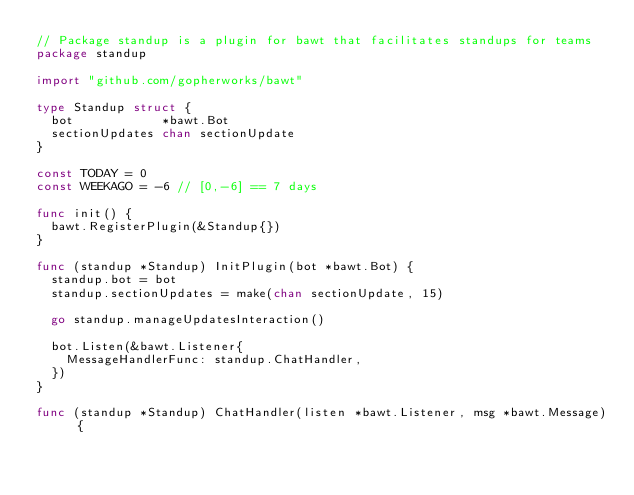<code> <loc_0><loc_0><loc_500><loc_500><_Go_>// Package standup is a plugin for bawt that facilitates standups for teams
package standup

import "github.com/gopherworks/bawt"

type Standup struct {
	bot            *bawt.Bot
	sectionUpdates chan sectionUpdate
}

const TODAY = 0
const WEEKAGO = -6 // [0,-6] == 7 days

func init() {
	bawt.RegisterPlugin(&Standup{})
}

func (standup *Standup) InitPlugin(bot *bawt.Bot) {
	standup.bot = bot
	standup.sectionUpdates = make(chan sectionUpdate, 15)

	go standup.manageUpdatesInteraction()

	bot.Listen(&bawt.Listener{
		MessageHandlerFunc: standup.ChatHandler,
	})
}

func (standup *Standup) ChatHandler(listen *bawt.Listener, msg *bawt.Message) {</code> 